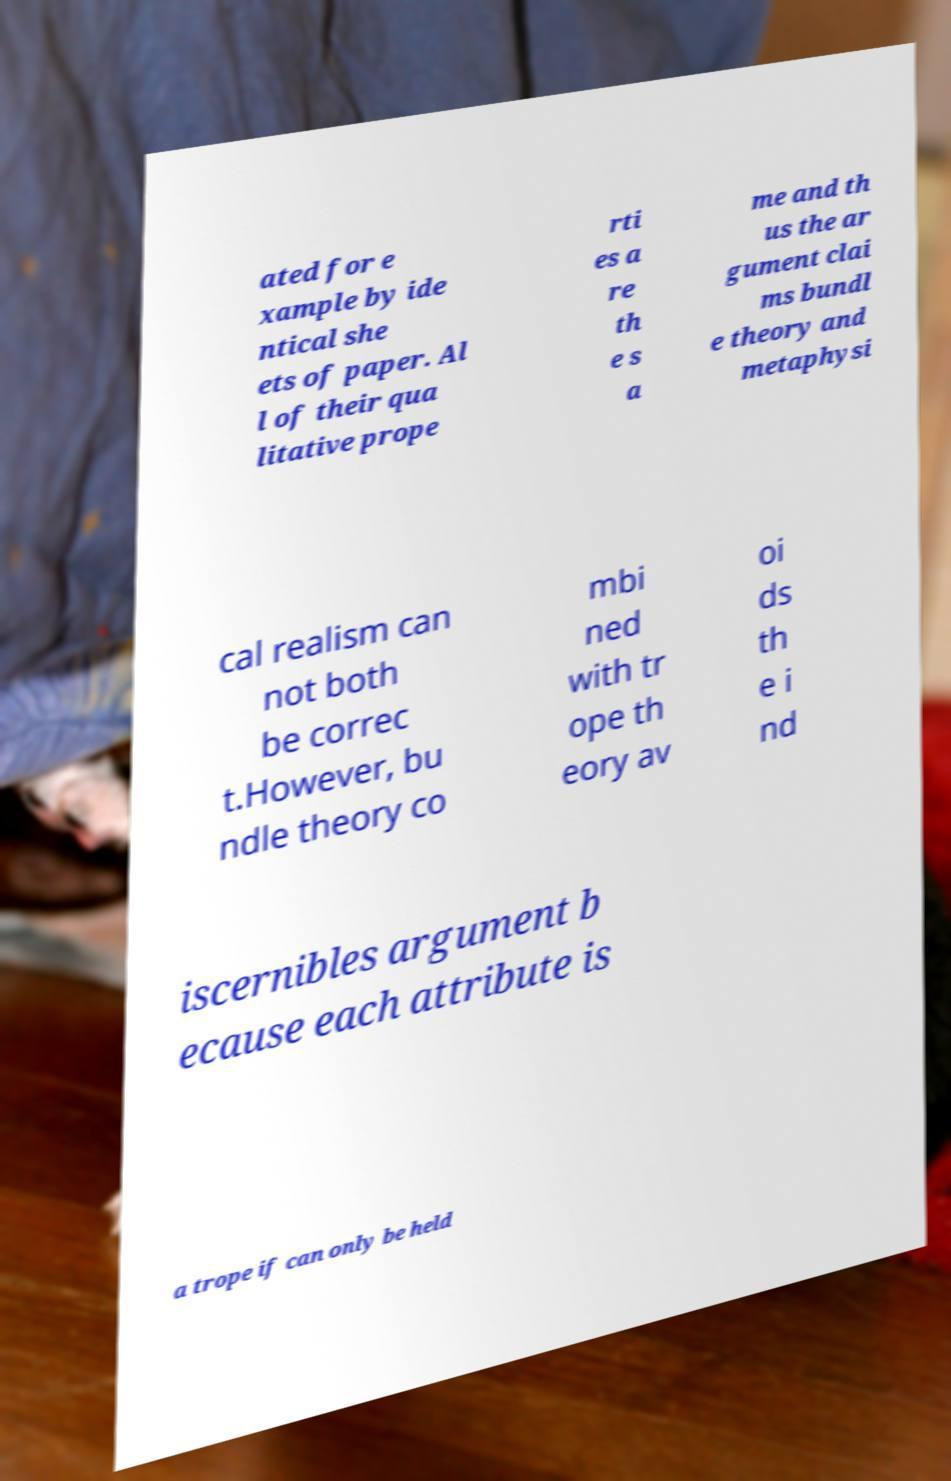Please read and relay the text visible in this image. What does it say? ated for e xample by ide ntical she ets of paper. Al l of their qua litative prope rti es a re th e s a me and th us the ar gument clai ms bundl e theory and metaphysi cal realism can not both be correc t.However, bu ndle theory co mbi ned with tr ope th eory av oi ds th e i nd iscernibles argument b ecause each attribute is a trope if can only be held 